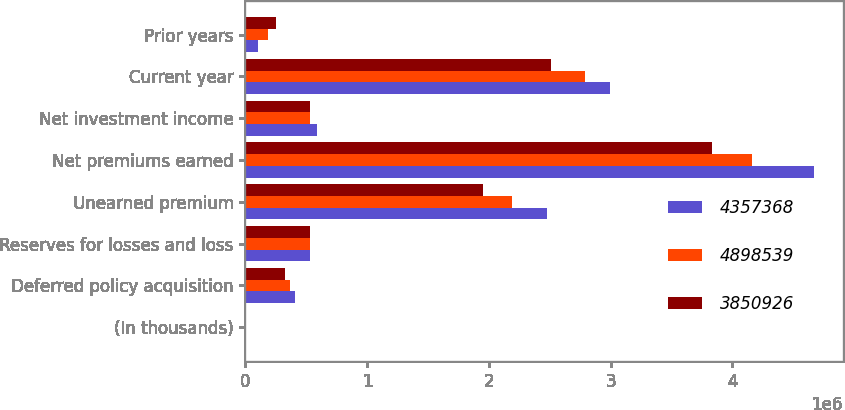<chart> <loc_0><loc_0><loc_500><loc_500><stacked_bar_chart><ecel><fcel>(In thousands)<fcel>Deferred policy acquisition<fcel>Reserves for losses and loss<fcel>Unearned premium<fcel>Net premiums earned<fcel>Net investment income<fcel>Current year<fcel>Prior years<nl><fcel>4.35737e+06<fcel>2012<fcel>404047<fcel>530525<fcel>2.47485e+06<fcel>4.67352e+06<fcel>586763<fcel>2.998e+06<fcel>102571<nl><fcel>4.89854e+06<fcel>2011<fcel>364937<fcel>530525<fcel>2.18958e+06<fcel>4.16087e+06<fcel>526351<fcel>2.79186e+06<fcel>181282<nl><fcel>3.85093e+06<fcel>2010<fcel>327282<fcel>530525<fcel>1.95372e+06<fcel>3.83558e+06<fcel>530525<fcel>2.50993e+06<fcel>253248<nl></chart> 